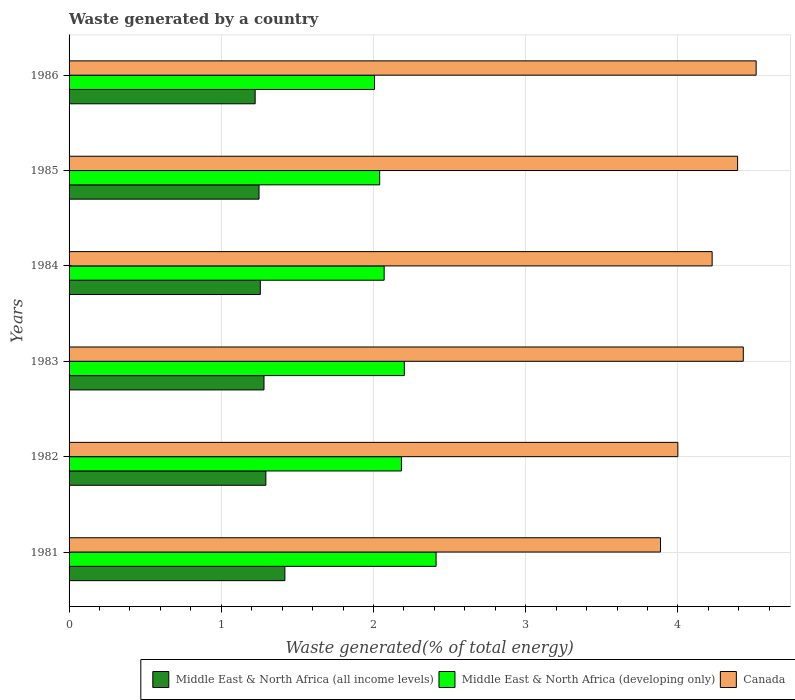How many different coloured bars are there?
Offer a terse response. 3. How many groups of bars are there?
Provide a short and direct response. 6. Are the number of bars per tick equal to the number of legend labels?
Offer a terse response. Yes. Are the number of bars on each tick of the Y-axis equal?
Your answer should be compact. Yes. How many bars are there on the 5th tick from the bottom?
Your answer should be very brief. 3. In how many cases, is the number of bars for a given year not equal to the number of legend labels?
Provide a succinct answer. 0. What is the total waste generated in Middle East & North Africa (all income levels) in 1984?
Ensure brevity in your answer.  1.26. Across all years, what is the maximum total waste generated in Canada?
Give a very brief answer. 4.51. Across all years, what is the minimum total waste generated in Canada?
Make the answer very short. 3.89. In which year was the total waste generated in Middle East & North Africa (developing only) minimum?
Your answer should be compact. 1986. What is the total total waste generated in Canada in the graph?
Offer a very short reply. 25.44. What is the difference between the total waste generated in Canada in 1983 and that in 1986?
Provide a short and direct response. -0.08. What is the difference between the total waste generated in Canada in 1981 and the total waste generated in Middle East & North Africa (all income levels) in 1985?
Offer a very short reply. 2.64. What is the average total waste generated in Canada per year?
Ensure brevity in your answer.  4.24. In the year 1984, what is the difference between the total waste generated in Middle East & North Africa (all income levels) and total waste generated in Canada?
Make the answer very short. -2.97. What is the ratio of the total waste generated in Middle East & North Africa (all income levels) in 1984 to that in 1986?
Make the answer very short. 1.03. Is the total waste generated in Canada in 1981 less than that in 1984?
Give a very brief answer. Yes. What is the difference between the highest and the second highest total waste generated in Canada?
Ensure brevity in your answer.  0.08. What is the difference between the highest and the lowest total waste generated in Middle East & North Africa (developing only)?
Offer a terse response. 0.4. In how many years, is the total waste generated in Middle East & North Africa (all income levels) greater than the average total waste generated in Middle East & North Africa (all income levels) taken over all years?
Offer a very short reply. 2. Is the sum of the total waste generated in Canada in 1983 and 1984 greater than the maximum total waste generated in Middle East & North Africa (developing only) across all years?
Provide a short and direct response. Yes. What does the 3rd bar from the top in 1984 represents?
Give a very brief answer. Middle East & North Africa (all income levels). What does the 1st bar from the bottom in 1983 represents?
Your answer should be compact. Middle East & North Africa (all income levels). Are all the bars in the graph horizontal?
Provide a succinct answer. Yes. How many years are there in the graph?
Your answer should be compact. 6. Does the graph contain any zero values?
Offer a terse response. No. Does the graph contain grids?
Give a very brief answer. Yes. Where does the legend appear in the graph?
Make the answer very short. Bottom right. How many legend labels are there?
Provide a succinct answer. 3. How are the legend labels stacked?
Make the answer very short. Horizontal. What is the title of the graph?
Your answer should be very brief. Waste generated by a country. Does "Least developed countries" appear as one of the legend labels in the graph?
Provide a short and direct response. No. What is the label or title of the X-axis?
Offer a terse response. Waste generated(% of total energy). What is the label or title of the Y-axis?
Your response must be concise. Years. What is the Waste generated(% of total energy) of Middle East & North Africa (all income levels) in 1981?
Your answer should be very brief. 1.42. What is the Waste generated(% of total energy) of Middle East & North Africa (developing only) in 1981?
Provide a short and direct response. 2.41. What is the Waste generated(% of total energy) in Canada in 1981?
Your response must be concise. 3.89. What is the Waste generated(% of total energy) of Middle East & North Africa (all income levels) in 1982?
Give a very brief answer. 1.29. What is the Waste generated(% of total energy) of Middle East & North Africa (developing only) in 1982?
Your response must be concise. 2.18. What is the Waste generated(% of total energy) in Canada in 1982?
Provide a succinct answer. 4. What is the Waste generated(% of total energy) of Middle East & North Africa (all income levels) in 1983?
Give a very brief answer. 1.28. What is the Waste generated(% of total energy) in Middle East & North Africa (developing only) in 1983?
Your response must be concise. 2.2. What is the Waste generated(% of total energy) of Canada in 1983?
Offer a very short reply. 4.43. What is the Waste generated(% of total energy) of Middle East & North Africa (all income levels) in 1984?
Your response must be concise. 1.26. What is the Waste generated(% of total energy) in Middle East & North Africa (developing only) in 1984?
Your response must be concise. 2.07. What is the Waste generated(% of total energy) in Canada in 1984?
Provide a short and direct response. 4.22. What is the Waste generated(% of total energy) of Middle East & North Africa (all income levels) in 1985?
Give a very brief answer. 1.25. What is the Waste generated(% of total energy) of Middle East & North Africa (developing only) in 1985?
Ensure brevity in your answer.  2.04. What is the Waste generated(% of total energy) in Canada in 1985?
Ensure brevity in your answer.  4.39. What is the Waste generated(% of total energy) in Middle East & North Africa (all income levels) in 1986?
Offer a terse response. 1.22. What is the Waste generated(% of total energy) in Middle East & North Africa (developing only) in 1986?
Offer a very short reply. 2.01. What is the Waste generated(% of total energy) of Canada in 1986?
Offer a terse response. 4.51. Across all years, what is the maximum Waste generated(% of total energy) in Middle East & North Africa (all income levels)?
Make the answer very short. 1.42. Across all years, what is the maximum Waste generated(% of total energy) of Middle East & North Africa (developing only)?
Provide a short and direct response. 2.41. Across all years, what is the maximum Waste generated(% of total energy) in Canada?
Offer a terse response. 4.51. Across all years, what is the minimum Waste generated(% of total energy) in Middle East & North Africa (all income levels)?
Provide a succinct answer. 1.22. Across all years, what is the minimum Waste generated(% of total energy) of Middle East & North Africa (developing only)?
Offer a terse response. 2.01. Across all years, what is the minimum Waste generated(% of total energy) in Canada?
Offer a very short reply. 3.89. What is the total Waste generated(% of total energy) in Middle East & North Africa (all income levels) in the graph?
Provide a short and direct response. 7.72. What is the total Waste generated(% of total energy) in Middle East & North Africa (developing only) in the graph?
Keep it short and to the point. 12.91. What is the total Waste generated(% of total energy) of Canada in the graph?
Make the answer very short. 25.45. What is the difference between the Waste generated(% of total energy) in Middle East & North Africa (all income levels) in 1981 and that in 1982?
Provide a succinct answer. 0.13. What is the difference between the Waste generated(% of total energy) in Middle East & North Africa (developing only) in 1981 and that in 1982?
Provide a succinct answer. 0.23. What is the difference between the Waste generated(% of total energy) of Canada in 1981 and that in 1982?
Your answer should be compact. -0.11. What is the difference between the Waste generated(% of total energy) in Middle East & North Africa (all income levels) in 1981 and that in 1983?
Offer a terse response. 0.14. What is the difference between the Waste generated(% of total energy) in Middle East & North Africa (developing only) in 1981 and that in 1983?
Make the answer very short. 0.21. What is the difference between the Waste generated(% of total energy) of Canada in 1981 and that in 1983?
Ensure brevity in your answer.  -0.54. What is the difference between the Waste generated(% of total energy) in Middle East & North Africa (all income levels) in 1981 and that in 1984?
Your answer should be very brief. 0.16. What is the difference between the Waste generated(% of total energy) in Middle East & North Africa (developing only) in 1981 and that in 1984?
Keep it short and to the point. 0.34. What is the difference between the Waste generated(% of total energy) of Canada in 1981 and that in 1984?
Provide a short and direct response. -0.34. What is the difference between the Waste generated(% of total energy) of Middle East & North Africa (all income levels) in 1981 and that in 1985?
Provide a short and direct response. 0.17. What is the difference between the Waste generated(% of total energy) of Middle East & North Africa (developing only) in 1981 and that in 1985?
Offer a very short reply. 0.37. What is the difference between the Waste generated(% of total energy) of Canada in 1981 and that in 1985?
Your response must be concise. -0.51. What is the difference between the Waste generated(% of total energy) in Middle East & North Africa (all income levels) in 1981 and that in 1986?
Your answer should be very brief. 0.2. What is the difference between the Waste generated(% of total energy) of Middle East & North Africa (developing only) in 1981 and that in 1986?
Provide a short and direct response. 0.4. What is the difference between the Waste generated(% of total energy) of Canada in 1981 and that in 1986?
Provide a short and direct response. -0.63. What is the difference between the Waste generated(% of total energy) in Middle East & North Africa (all income levels) in 1982 and that in 1983?
Keep it short and to the point. 0.01. What is the difference between the Waste generated(% of total energy) in Middle East & North Africa (developing only) in 1982 and that in 1983?
Offer a terse response. -0.02. What is the difference between the Waste generated(% of total energy) of Canada in 1982 and that in 1983?
Offer a very short reply. -0.43. What is the difference between the Waste generated(% of total energy) of Middle East & North Africa (all income levels) in 1982 and that in 1984?
Make the answer very short. 0.04. What is the difference between the Waste generated(% of total energy) in Middle East & North Africa (developing only) in 1982 and that in 1984?
Offer a very short reply. 0.11. What is the difference between the Waste generated(% of total energy) in Canada in 1982 and that in 1984?
Ensure brevity in your answer.  -0.23. What is the difference between the Waste generated(% of total energy) of Middle East & North Africa (all income levels) in 1982 and that in 1985?
Make the answer very short. 0.04. What is the difference between the Waste generated(% of total energy) of Middle East & North Africa (developing only) in 1982 and that in 1985?
Give a very brief answer. 0.14. What is the difference between the Waste generated(% of total energy) in Canada in 1982 and that in 1985?
Provide a short and direct response. -0.39. What is the difference between the Waste generated(% of total energy) of Middle East & North Africa (all income levels) in 1982 and that in 1986?
Your answer should be compact. 0.07. What is the difference between the Waste generated(% of total energy) in Middle East & North Africa (developing only) in 1982 and that in 1986?
Ensure brevity in your answer.  0.18. What is the difference between the Waste generated(% of total energy) in Canada in 1982 and that in 1986?
Your answer should be very brief. -0.51. What is the difference between the Waste generated(% of total energy) of Middle East & North Africa (all income levels) in 1983 and that in 1984?
Your answer should be compact. 0.02. What is the difference between the Waste generated(% of total energy) of Middle East & North Africa (developing only) in 1983 and that in 1984?
Offer a very short reply. 0.13. What is the difference between the Waste generated(% of total energy) of Canada in 1983 and that in 1984?
Ensure brevity in your answer.  0.2. What is the difference between the Waste generated(% of total energy) in Middle East & North Africa (all income levels) in 1983 and that in 1985?
Keep it short and to the point. 0.03. What is the difference between the Waste generated(% of total energy) in Middle East & North Africa (developing only) in 1983 and that in 1985?
Offer a terse response. 0.16. What is the difference between the Waste generated(% of total energy) in Canada in 1983 and that in 1985?
Ensure brevity in your answer.  0.04. What is the difference between the Waste generated(% of total energy) in Middle East & North Africa (all income levels) in 1983 and that in 1986?
Keep it short and to the point. 0.06. What is the difference between the Waste generated(% of total energy) of Middle East & North Africa (developing only) in 1983 and that in 1986?
Give a very brief answer. 0.2. What is the difference between the Waste generated(% of total energy) of Canada in 1983 and that in 1986?
Your answer should be compact. -0.08. What is the difference between the Waste generated(% of total energy) of Middle East & North Africa (all income levels) in 1984 and that in 1985?
Keep it short and to the point. 0.01. What is the difference between the Waste generated(% of total energy) in Middle East & North Africa (developing only) in 1984 and that in 1985?
Offer a terse response. 0.03. What is the difference between the Waste generated(% of total energy) of Canada in 1984 and that in 1985?
Your response must be concise. -0.17. What is the difference between the Waste generated(% of total energy) in Middle East & North Africa (all income levels) in 1984 and that in 1986?
Your answer should be very brief. 0.03. What is the difference between the Waste generated(% of total energy) in Middle East & North Africa (developing only) in 1984 and that in 1986?
Offer a terse response. 0.06. What is the difference between the Waste generated(% of total energy) of Canada in 1984 and that in 1986?
Your answer should be compact. -0.29. What is the difference between the Waste generated(% of total energy) of Middle East & North Africa (all income levels) in 1985 and that in 1986?
Offer a very short reply. 0.03. What is the difference between the Waste generated(% of total energy) of Middle East & North Africa (developing only) in 1985 and that in 1986?
Provide a succinct answer. 0.03. What is the difference between the Waste generated(% of total energy) of Canada in 1985 and that in 1986?
Offer a very short reply. -0.12. What is the difference between the Waste generated(% of total energy) in Middle East & North Africa (all income levels) in 1981 and the Waste generated(% of total energy) in Middle East & North Africa (developing only) in 1982?
Provide a short and direct response. -0.77. What is the difference between the Waste generated(% of total energy) in Middle East & North Africa (all income levels) in 1981 and the Waste generated(% of total energy) in Canada in 1982?
Offer a very short reply. -2.58. What is the difference between the Waste generated(% of total energy) of Middle East & North Africa (developing only) in 1981 and the Waste generated(% of total energy) of Canada in 1982?
Offer a very short reply. -1.59. What is the difference between the Waste generated(% of total energy) of Middle East & North Africa (all income levels) in 1981 and the Waste generated(% of total energy) of Middle East & North Africa (developing only) in 1983?
Offer a very short reply. -0.78. What is the difference between the Waste generated(% of total energy) of Middle East & North Africa (all income levels) in 1981 and the Waste generated(% of total energy) of Canada in 1983?
Your answer should be very brief. -3.01. What is the difference between the Waste generated(% of total energy) in Middle East & North Africa (developing only) in 1981 and the Waste generated(% of total energy) in Canada in 1983?
Offer a very short reply. -2.02. What is the difference between the Waste generated(% of total energy) in Middle East & North Africa (all income levels) in 1981 and the Waste generated(% of total energy) in Middle East & North Africa (developing only) in 1984?
Your answer should be very brief. -0.65. What is the difference between the Waste generated(% of total energy) in Middle East & North Africa (all income levels) in 1981 and the Waste generated(% of total energy) in Canada in 1984?
Ensure brevity in your answer.  -2.81. What is the difference between the Waste generated(% of total energy) in Middle East & North Africa (developing only) in 1981 and the Waste generated(% of total energy) in Canada in 1984?
Give a very brief answer. -1.81. What is the difference between the Waste generated(% of total energy) of Middle East & North Africa (all income levels) in 1981 and the Waste generated(% of total energy) of Middle East & North Africa (developing only) in 1985?
Your response must be concise. -0.62. What is the difference between the Waste generated(% of total energy) of Middle East & North Africa (all income levels) in 1981 and the Waste generated(% of total energy) of Canada in 1985?
Offer a very short reply. -2.97. What is the difference between the Waste generated(% of total energy) of Middle East & North Africa (developing only) in 1981 and the Waste generated(% of total energy) of Canada in 1985?
Offer a terse response. -1.98. What is the difference between the Waste generated(% of total energy) of Middle East & North Africa (all income levels) in 1981 and the Waste generated(% of total energy) of Middle East & North Africa (developing only) in 1986?
Your response must be concise. -0.59. What is the difference between the Waste generated(% of total energy) of Middle East & North Africa (all income levels) in 1981 and the Waste generated(% of total energy) of Canada in 1986?
Your answer should be very brief. -3.1. What is the difference between the Waste generated(% of total energy) in Middle East & North Africa (developing only) in 1981 and the Waste generated(% of total energy) in Canada in 1986?
Make the answer very short. -2.1. What is the difference between the Waste generated(% of total energy) in Middle East & North Africa (all income levels) in 1982 and the Waste generated(% of total energy) in Middle East & North Africa (developing only) in 1983?
Provide a succinct answer. -0.91. What is the difference between the Waste generated(% of total energy) of Middle East & North Africa (all income levels) in 1982 and the Waste generated(% of total energy) of Canada in 1983?
Give a very brief answer. -3.14. What is the difference between the Waste generated(% of total energy) in Middle East & North Africa (developing only) in 1982 and the Waste generated(% of total energy) in Canada in 1983?
Provide a succinct answer. -2.25. What is the difference between the Waste generated(% of total energy) of Middle East & North Africa (all income levels) in 1982 and the Waste generated(% of total energy) of Middle East & North Africa (developing only) in 1984?
Make the answer very short. -0.78. What is the difference between the Waste generated(% of total energy) of Middle East & North Africa (all income levels) in 1982 and the Waste generated(% of total energy) of Canada in 1984?
Make the answer very short. -2.93. What is the difference between the Waste generated(% of total energy) in Middle East & North Africa (developing only) in 1982 and the Waste generated(% of total energy) in Canada in 1984?
Provide a succinct answer. -2.04. What is the difference between the Waste generated(% of total energy) of Middle East & North Africa (all income levels) in 1982 and the Waste generated(% of total energy) of Middle East & North Africa (developing only) in 1985?
Provide a short and direct response. -0.75. What is the difference between the Waste generated(% of total energy) of Middle East & North Africa (all income levels) in 1982 and the Waste generated(% of total energy) of Canada in 1985?
Ensure brevity in your answer.  -3.1. What is the difference between the Waste generated(% of total energy) of Middle East & North Africa (developing only) in 1982 and the Waste generated(% of total energy) of Canada in 1985?
Your response must be concise. -2.21. What is the difference between the Waste generated(% of total energy) of Middle East & North Africa (all income levels) in 1982 and the Waste generated(% of total energy) of Middle East & North Africa (developing only) in 1986?
Ensure brevity in your answer.  -0.71. What is the difference between the Waste generated(% of total energy) of Middle East & North Africa (all income levels) in 1982 and the Waste generated(% of total energy) of Canada in 1986?
Offer a terse response. -3.22. What is the difference between the Waste generated(% of total energy) of Middle East & North Africa (developing only) in 1982 and the Waste generated(% of total energy) of Canada in 1986?
Your response must be concise. -2.33. What is the difference between the Waste generated(% of total energy) of Middle East & North Africa (all income levels) in 1983 and the Waste generated(% of total energy) of Middle East & North Africa (developing only) in 1984?
Provide a short and direct response. -0.79. What is the difference between the Waste generated(% of total energy) in Middle East & North Africa (all income levels) in 1983 and the Waste generated(% of total energy) in Canada in 1984?
Your answer should be compact. -2.94. What is the difference between the Waste generated(% of total energy) of Middle East & North Africa (developing only) in 1983 and the Waste generated(% of total energy) of Canada in 1984?
Provide a short and direct response. -2.02. What is the difference between the Waste generated(% of total energy) of Middle East & North Africa (all income levels) in 1983 and the Waste generated(% of total energy) of Middle East & North Africa (developing only) in 1985?
Give a very brief answer. -0.76. What is the difference between the Waste generated(% of total energy) of Middle East & North Africa (all income levels) in 1983 and the Waste generated(% of total energy) of Canada in 1985?
Your response must be concise. -3.11. What is the difference between the Waste generated(% of total energy) in Middle East & North Africa (developing only) in 1983 and the Waste generated(% of total energy) in Canada in 1985?
Your response must be concise. -2.19. What is the difference between the Waste generated(% of total energy) of Middle East & North Africa (all income levels) in 1983 and the Waste generated(% of total energy) of Middle East & North Africa (developing only) in 1986?
Ensure brevity in your answer.  -0.73. What is the difference between the Waste generated(% of total energy) of Middle East & North Africa (all income levels) in 1983 and the Waste generated(% of total energy) of Canada in 1986?
Offer a very short reply. -3.23. What is the difference between the Waste generated(% of total energy) in Middle East & North Africa (developing only) in 1983 and the Waste generated(% of total energy) in Canada in 1986?
Your response must be concise. -2.31. What is the difference between the Waste generated(% of total energy) of Middle East & North Africa (all income levels) in 1984 and the Waste generated(% of total energy) of Middle East & North Africa (developing only) in 1985?
Make the answer very short. -0.78. What is the difference between the Waste generated(% of total energy) in Middle East & North Africa (all income levels) in 1984 and the Waste generated(% of total energy) in Canada in 1985?
Provide a succinct answer. -3.14. What is the difference between the Waste generated(% of total energy) of Middle East & North Africa (developing only) in 1984 and the Waste generated(% of total energy) of Canada in 1985?
Offer a terse response. -2.32. What is the difference between the Waste generated(% of total energy) of Middle East & North Africa (all income levels) in 1984 and the Waste generated(% of total energy) of Middle East & North Africa (developing only) in 1986?
Offer a very short reply. -0.75. What is the difference between the Waste generated(% of total energy) in Middle East & North Africa (all income levels) in 1984 and the Waste generated(% of total energy) in Canada in 1986?
Provide a succinct answer. -3.26. What is the difference between the Waste generated(% of total energy) in Middle East & North Africa (developing only) in 1984 and the Waste generated(% of total energy) in Canada in 1986?
Keep it short and to the point. -2.44. What is the difference between the Waste generated(% of total energy) of Middle East & North Africa (all income levels) in 1985 and the Waste generated(% of total energy) of Middle East & North Africa (developing only) in 1986?
Give a very brief answer. -0.76. What is the difference between the Waste generated(% of total energy) in Middle East & North Africa (all income levels) in 1985 and the Waste generated(% of total energy) in Canada in 1986?
Provide a short and direct response. -3.27. What is the difference between the Waste generated(% of total energy) in Middle East & North Africa (developing only) in 1985 and the Waste generated(% of total energy) in Canada in 1986?
Offer a terse response. -2.47. What is the average Waste generated(% of total energy) in Middle East & North Africa (all income levels) per year?
Your answer should be very brief. 1.29. What is the average Waste generated(% of total energy) in Middle East & North Africa (developing only) per year?
Your answer should be compact. 2.15. What is the average Waste generated(% of total energy) of Canada per year?
Provide a short and direct response. 4.24. In the year 1981, what is the difference between the Waste generated(% of total energy) in Middle East & North Africa (all income levels) and Waste generated(% of total energy) in Middle East & North Africa (developing only)?
Provide a succinct answer. -0.99. In the year 1981, what is the difference between the Waste generated(% of total energy) in Middle East & North Africa (all income levels) and Waste generated(% of total energy) in Canada?
Make the answer very short. -2.47. In the year 1981, what is the difference between the Waste generated(% of total energy) in Middle East & North Africa (developing only) and Waste generated(% of total energy) in Canada?
Offer a terse response. -1.47. In the year 1982, what is the difference between the Waste generated(% of total energy) in Middle East & North Africa (all income levels) and Waste generated(% of total energy) in Middle East & North Africa (developing only)?
Your response must be concise. -0.89. In the year 1982, what is the difference between the Waste generated(% of total energy) of Middle East & North Africa (all income levels) and Waste generated(% of total energy) of Canada?
Your answer should be very brief. -2.71. In the year 1982, what is the difference between the Waste generated(% of total energy) in Middle East & North Africa (developing only) and Waste generated(% of total energy) in Canada?
Offer a very short reply. -1.82. In the year 1983, what is the difference between the Waste generated(% of total energy) in Middle East & North Africa (all income levels) and Waste generated(% of total energy) in Middle East & North Africa (developing only)?
Offer a terse response. -0.92. In the year 1983, what is the difference between the Waste generated(% of total energy) of Middle East & North Africa (all income levels) and Waste generated(% of total energy) of Canada?
Provide a short and direct response. -3.15. In the year 1983, what is the difference between the Waste generated(% of total energy) of Middle East & North Africa (developing only) and Waste generated(% of total energy) of Canada?
Make the answer very short. -2.23. In the year 1984, what is the difference between the Waste generated(% of total energy) of Middle East & North Africa (all income levels) and Waste generated(% of total energy) of Middle East & North Africa (developing only)?
Your response must be concise. -0.81. In the year 1984, what is the difference between the Waste generated(% of total energy) of Middle East & North Africa (all income levels) and Waste generated(% of total energy) of Canada?
Provide a short and direct response. -2.97. In the year 1984, what is the difference between the Waste generated(% of total energy) of Middle East & North Africa (developing only) and Waste generated(% of total energy) of Canada?
Your answer should be compact. -2.15. In the year 1985, what is the difference between the Waste generated(% of total energy) of Middle East & North Africa (all income levels) and Waste generated(% of total energy) of Middle East & North Africa (developing only)?
Your response must be concise. -0.79. In the year 1985, what is the difference between the Waste generated(% of total energy) of Middle East & North Africa (all income levels) and Waste generated(% of total energy) of Canada?
Offer a terse response. -3.14. In the year 1985, what is the difference between the Waste generated(% of total energy) in Middle East & North Africa (developing only) and Waste generated(% of total energy) in Canada?
Ensure brevity in your answer.  -2.35. In the year 1986, what is the difference between the Waste generated(% of total energy) of Middle East & North Africa (all income levels) and Waste generated(% of total energy) of Middle East & North Africa (developing only)?
Your answer should be very brief. -0.78. In the year 1986, what is the difference between the Waste generated(% of total energy) of Middle East & North Africa (all income levels) and Waste generated(% of total energy) of Canada?
Offer a terse response. -3.29. In the year 1986, what is the difference between the Waste generated(% of total energy) in Middle East & North Africa (developing only) and Waste generated(% of total energy) in Canada?
Your response must be concise. -2.51. What is the ratio of the Waste generated(% of total energy) of Middle East & North Africa (all income levels) in 1981 to that in 1982?
Your answer should be very brief. 1.1. What is the ratio of the Waste generated(% of total energy) of Middle East & North Africa (developing only) in 1981 to that in 1982?
Offer a terse response. 1.1. What is the ratio of the Waste generated(% of total energy) in Canada in 1981 to that in 1982?
Your response must be concise. 0.97. What is the ratio of the Waste generated(% of total energy) of Middle East & North Africa (all income levels) in 1981 to that in 1983?
Provide a succinct answer. 1.11. What is the ratio of the Waste generated(% of total energy) in Middle East & North Africa (developing only) in 1981 to that in 1983?
Your response must be concise. 1.09. What is the ratio of the Waste generated(% of total energy) of Canada in 1981 to that in 1983?
Give a very brief answer. 0.88. What is the ratio of the Waste generated(% of total energy) in Middle East & North Africa (all income levels) in 1981 to that in 1984?
Your answer should be very brief. 1.13. What is the ratio of the Waste generated(% of total energy) of Middle East & North Africa (developing only) in 1981 to that in 1984?
Offer a terse response. 1.16. What is the ratio of the Waste generated(% of total energy) of Canada in 1981 to that in 1984?
Your answer should be very brief. 0.92. What is the ratio of the Waste generated(% of total energy) in Middle East & North Africa (all income levels) in 1981 to that in 1985?
Your answer should be compact. 1.14. What is the ratio of the Waste generated(% of total energy) in Middle East & North Africa (developing only) in 1981 to that in 1985?
Your answer should be compact. 1.18. What is the ratio of the Waste generated(% of total energy) in Canada in 1981 to that in 1985?
Make the answer very short. 0.88. What is the ratio of the Waste generated(% of total energy) of Middle East & North Africa (all income levels) in 1981 to that in 1986?
Your answer should be very brief. 1.16. What is the ratio of the Waste generated(% of total energy) in Middle East & North Africa (developing only) in 1981 to that in 1986?
Your answer should be very brief. 1.2. What is the ratio of the Waste generated(% of total energy) in Canada in 1981 to that in 1986?
Keep it short and to the point. 0.86. What is the ratio of the Waste generated(% of total energy) in Middle East & North Africa (all income levels) in 1982 to that in 1983?
Offer a very short reply. 1.01. What is the ratio of the Waste generated(% of total energy) of Canada in 1982 to that in 1983?
Keep it short and to the point. 0.9. What is the ratio of the Waste generated(% of total energy) of Middle East & North Africa (developing only) in 1982 to that in 1984?
Your answer should be compact. 1.05. What is the ratio of the Waste generated(% of total energy) in Canada in 1982 to that in 1984?
Offer a terse response. 0.95. What is the ratio of the Waste generated(% of total energy) in Middle East & North Africa (all income levels) in 1982 to that in 1985?
Your response must be concise. 1.04. What is the ratio of the Waste generated(% of total energy) in Middle East & North Africa (developing only) in 1982 to that in 1985?
Provide a short and direct response. 1.07. What is the ratio of the Waste generated(% of total energy) in Canada in 1982 to that in 1985?
Provide a short and direct response. 0.91. What is the ratio of the Waste generated(% of total energy) of Middle East & North Africa (all income levels) in 1982 to that in 1986?
Offer a very short reply. 1.06. What is the ratio of the Waste generated(% of total energy) in Middle East & North Africa (developing only) in 1982 to that in 1986?
Offer a terse response. 1.09. What is the ratio of the Waste generated(% of total energy) in Canada in 1982 to that in 1986?
Offer a very short reply. 0.89. What is the ratio of the Waste generated(% of total energy) of Middle East & North Africa (all income levels) in 1983 to that in 1984?
Make the answer very short. 1.02. What is the ratio of the Waste generated(% of total energy) of Middle East & North Africa (developing only) in 1983 to that in 1984?
Provide a succinct answer. 1.06. What is the ratio of the Waste generated(% of total energy) of Canada in 1983 to that in 1984?
Make the answer very short. 1.05. What is the ratio of the Waste generated(% of total energy) in Middle East & North Africa (all income levels) in 1983 to that in 1985?
Your response must be concise. 1.03. What is the ratio of the Waste generated(% of total energy) of Middle East & North Africa (developing only) in 1983 to that in 1985?
Make the answer very short. 1.08. What is the ratio of the Waste generated(% of total energy) in Canada in 1983 to that in 1985?
Keep it short and to the point. 1.01. What is the ratio of the Waste generated(% of total energy) of Middle East & North Africa (all income levels) in 1983 to that in 1986?
Keep it short and to the point. 1.05. What is the ratio of the Waste generated(% of total energy) in Middle East & North Africa (developing only) in 1983 to that in 1986?
Make the answer very short. 1.1. What is the ratio of the Waste generated(% of total energy) in Canada in 1983 to that in 1986?
Give a very brief answer. 0.98. What is the ratio of the Waste generated(% of total energy) in Middle East & North Africa (all income levels) in 1984 to that in 1985?
Offer a very short reply. 1.01. What is the ratio of the Waste generated(% of total energy) in Middle East & North Africa (developing only) in 1984 to that in 1985?
Make the answer very short. 1.01. What is the ratio of the Waste generated(% of total energy) of Canada in 1984 to that in 1985?
Your answer should be very brief. 0.96. What is the ratio of the Waste generated(% of total energy) in Middle East & North Africa (all income levels) in 1984 to that in 1986?
Provide a succinct answer. 1.03. What is the ratio of the Waste generated(% of total energy) in Middle East & North Africa (developing only) in 1984 to that in 1986?
Provide a short and direct response. 1.03. What is the ratio of the Waste generated(% of total energy) of Canada in 1984 to that in 1986?
Ensure brevity in your answer.  0.94. What is the ratio of the Waste generated(% of total energy) of Middle East & North Africa (all income levels) in 1985 to that in 1986?
Your answer should be very brief. 1.02. What is the ratio of the Waste generated(% of total energy) in Middle East & North Africa (developing only) in 1985 to that in 1986?
Provide a succinct answer. 1.02. What is the difference between the highest and the second highest Waste generated(% of total energy) of Middle East & North Africa (all income levels)?
Keep it short and to the point. 0.13. What is the difference between the highest and the second highest Waste generated(% of total energy) of Middle East & North Africa (developing only)?
Keep it short and to the point. 0.21. What is the difference between the highest and the second highest Waste generated(% of total energy) of Canada?
Your response must be concise. 0.08. What is the difference between the highest and the lowest Waste generated(% of total energy) of Middle East & North Africa (all income levels)?
Offer a very short reply. 0.2. What is the difference between the highest and the lowest Waste generated(% of total energy) of Middle East & North Africa (developing only)?
Keep it short and to the point. 0.4. What is the difference between the highest and the lowest Waste generated(% of total energy) of Canada?
Make the answer very short. 0.63. 